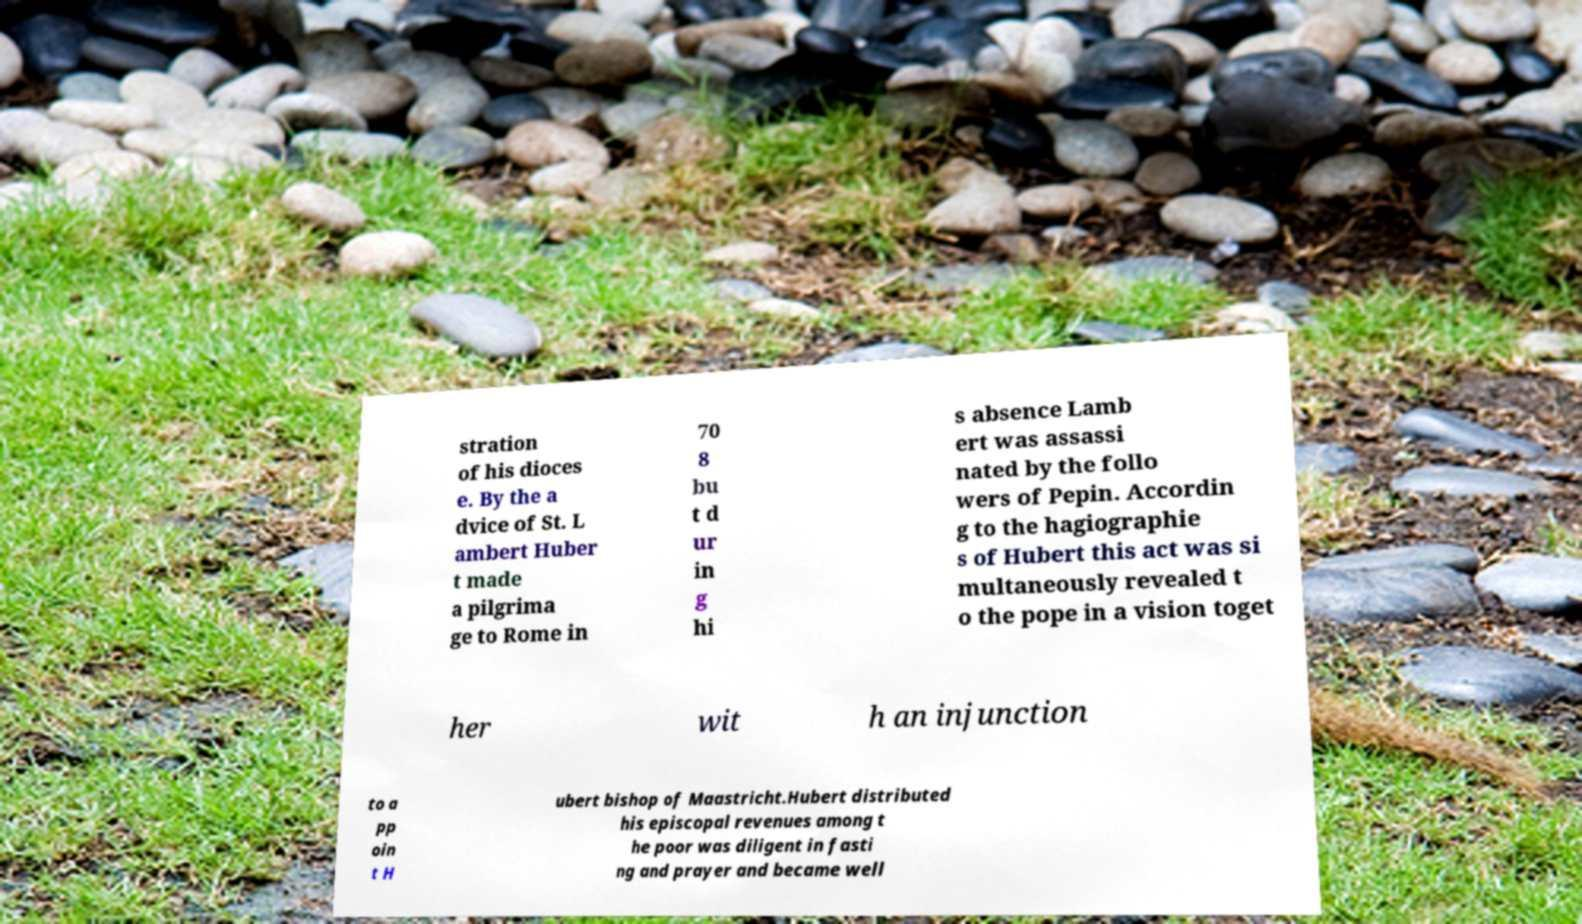For documentation purposes, I need the text within this image transcribed. Could you provide that? stration of his dioces e. By the a dvice of St. L ambert Huber t made a pilgrima ge to Rome in 70 8 bu t d ur in g hi s absence Lamb ert was assassi nated by the follo wers of Pepin. Accordin g to the hagiographie s of Hubert this act was si multaneously revealed t o the pope in a vision toget her wit h an injunction to a pp oin t H ubert bishop of Maastricht.Hubert distributed his episcopal revenues among t he poor was diligent in fasti ng and prayer and became well 